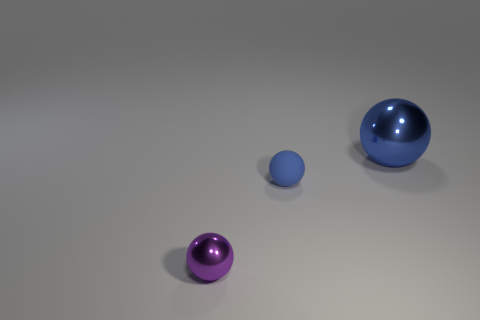Subtract all brown blocks. How many blue balls are left? 2 Subtract 1 balls. How many balls are left? 2 Add 3 brown cylinders. How many objects exist? 6 Add 2 tiny red blocks. How many tiny red blocks exist? 2 Subtract 1 purple spheres. How many objects are left? 2 Subtract all purple spheres. Subtract all large spheres. How many objects are left? 1 Add 2 tiny purple metal objects. How many tiny purple metal objects are left? 3 